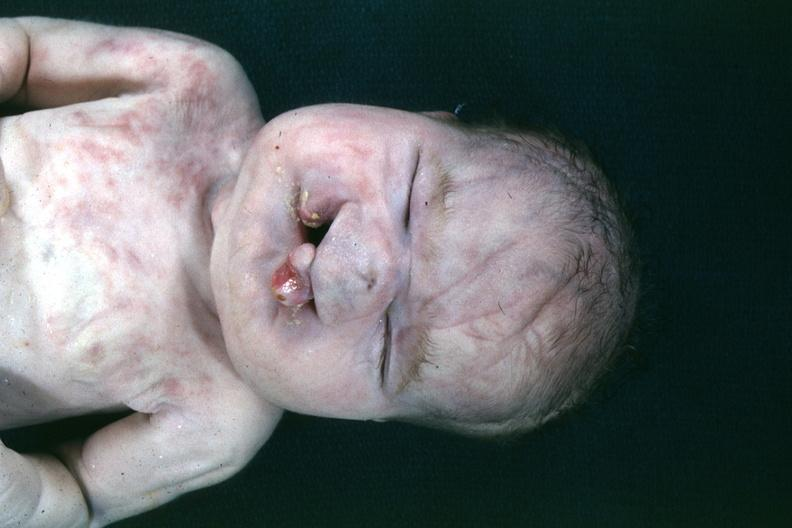what is present?
Answer the question using a single word or phrase. Face 